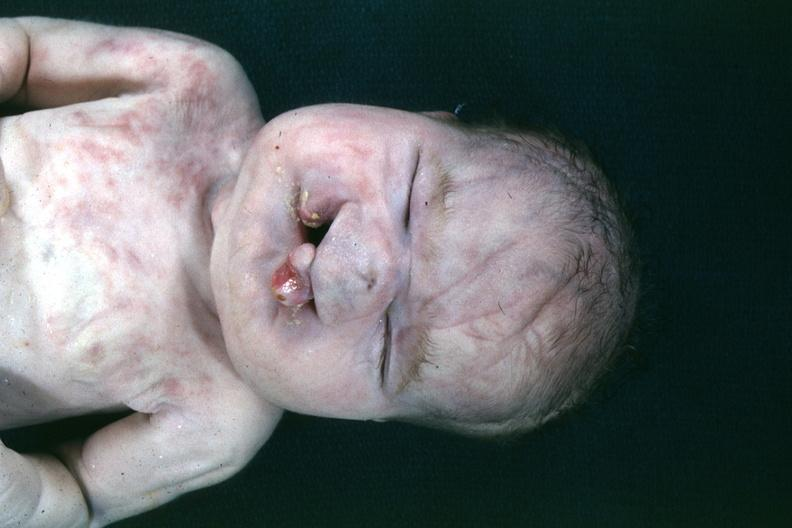what is present?
Answer the question using a single word or phrase. Face 